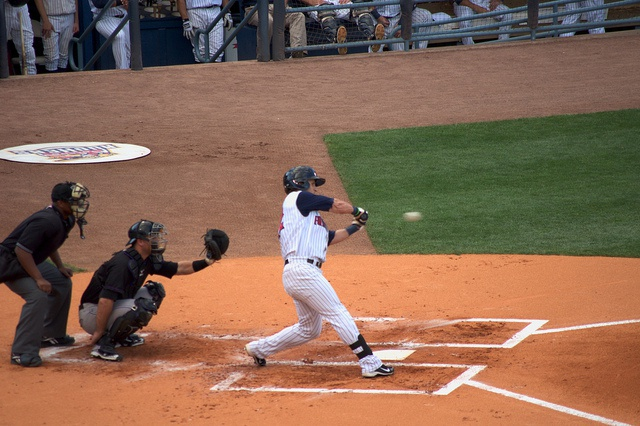Describe the objects in this image and their specific colors. I can see people in black, lavender, gray, and darkgray tones, people in black, maroon, and gray tones, people in black, gray, maroon, and brown tones, people in black, gray, and maroon tones, and people in black, gray, and maroon tones in this image. 